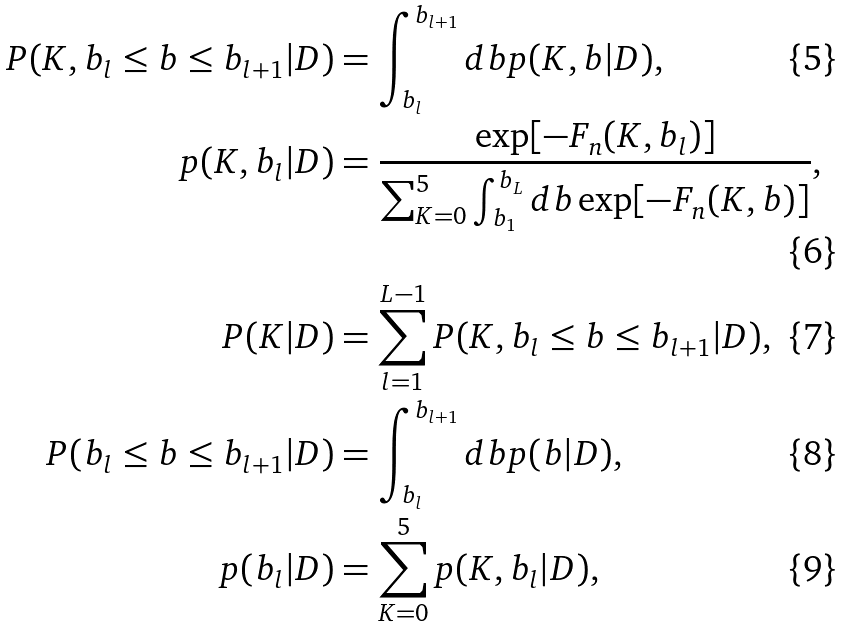Convert formula to latex. <formula><loc_0><loc_0><loc_500><loc_500>P ( K , b _ { l } \leq b \leq b _ { l + 1 } | D ) & = \int _ { b _ { l } } ^ { b _ { l + 1 } } d b p ( K , b | D ) , \\ p ( K , b _ { l } | D ) & = \frac { \exp [ - F _ { n } ( K , b _ { l } ) ] } { \sum _ { K = 0 } ^ { 5 } \int _ { b _ { 1 } } ^ { b _ { L } } d b \exp [ - F _ { n } ( K , b ) ] } , \\ P ( K | D ) & = \sum _ { l = 1 } ^ { L - 1 } P ( K , b _ { l } \leq b \leq b _ { l + 1 } | D ) , \\ P ( b _ { l } \leq b \leq b _ { l + 1 } | D ) & = \int _ { b _ { l } } ^ { b _ { l + 1 } } d b p ( b | D ) , \\ p ( b _ { l } | D ) & = \sum _ { K = 0 } ^ { 5 } p ( K , b _ { l } | D ) ,</formula> 